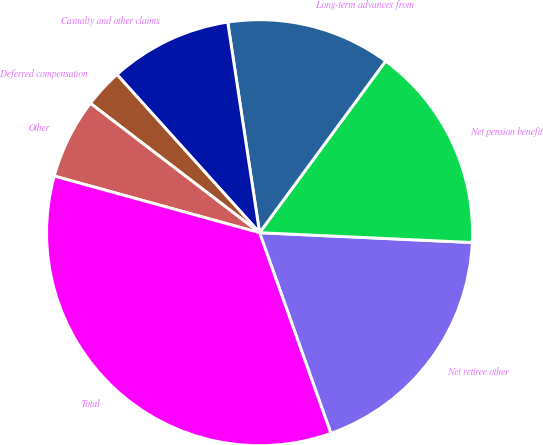Convert chart. <chart><loc_0><loc_0><loc_500><loc_500><pie_chart><fcel>Net retiree other<fcel>Net pension benefit<fcel>Long-term advances from<fcel>Casualty and other claims<fcel>Deferred compensation<fcel>Other<fcel>Total<nl><fcel>18.83%<fcel>15.65%<fcel>12.47%<fcel>9.29%<fcel>2.93%<fcel>6.11%<fcel>34.72%<nl></chart> 